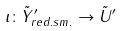Convert formula to latex. <formula><loc_0><loc_0><loc_500><loc_500>\iota \colon \tilde { Y } _ { r e d . s m . } ^ { \prime } \rightarrow \tilde { U } ^ { \prime }</formula> 